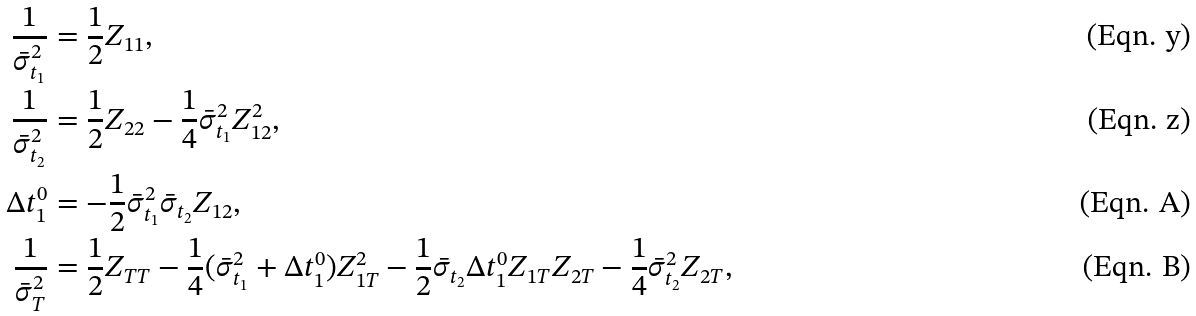<formula> <loc_0><loc_0><loc_500><loc_500>\frac { 1 } { \bar { \sigma } ^ { 2 } _ { t _ { 1 } } } & = \frac { 1 } { 2 } Z _ { 1 1 } , \\ \frac { 1 } { \bar { \sigma } ^ { 2 } _ { t _ { 2 } } } & = \frac { 1 } { 2 } Z _ { 2 2 } - \frac { 1 } { 4 } \bar { \sigma } ^ { 2 } _ { t _ { 1 } } Z _ { 1 2 } ^ { 2 } , \\ \Delta t ^ { 0 } _ { 1 } & = - \frac { 1 } { 2 } \bar { \sigma } ^ { 2 } _ { t _ { 1 } } \bar { \sigma } _ { t _ { 2 } } Z _ { 1 2 } , \\ \frac { 1 } { \bar { \sigma } ^ { 2 } _ { T } } & = \frac { 1 } { 2 } Z _ { T T } - \frac { 1 } { 4 } ( \bar { \sigma } ^ { 2 } _ { t _ { 1 } } + \Delta t ^ { 0 } _ { 1 } ) Z _ { 1 T } ^ { 2 } - \frac { 1 } { 2 } \bar { \sigma } _ { t _ { 2 } } \Delta t ^ { 0 } _ { 1 } Z _ { 1 T } Z _ { 2 T } - \frac { 1 } { 4 } \bar { \sigma } ^ { 2 } _ { t _ { 2 } } Z _ { 2 T } ,</formula> 